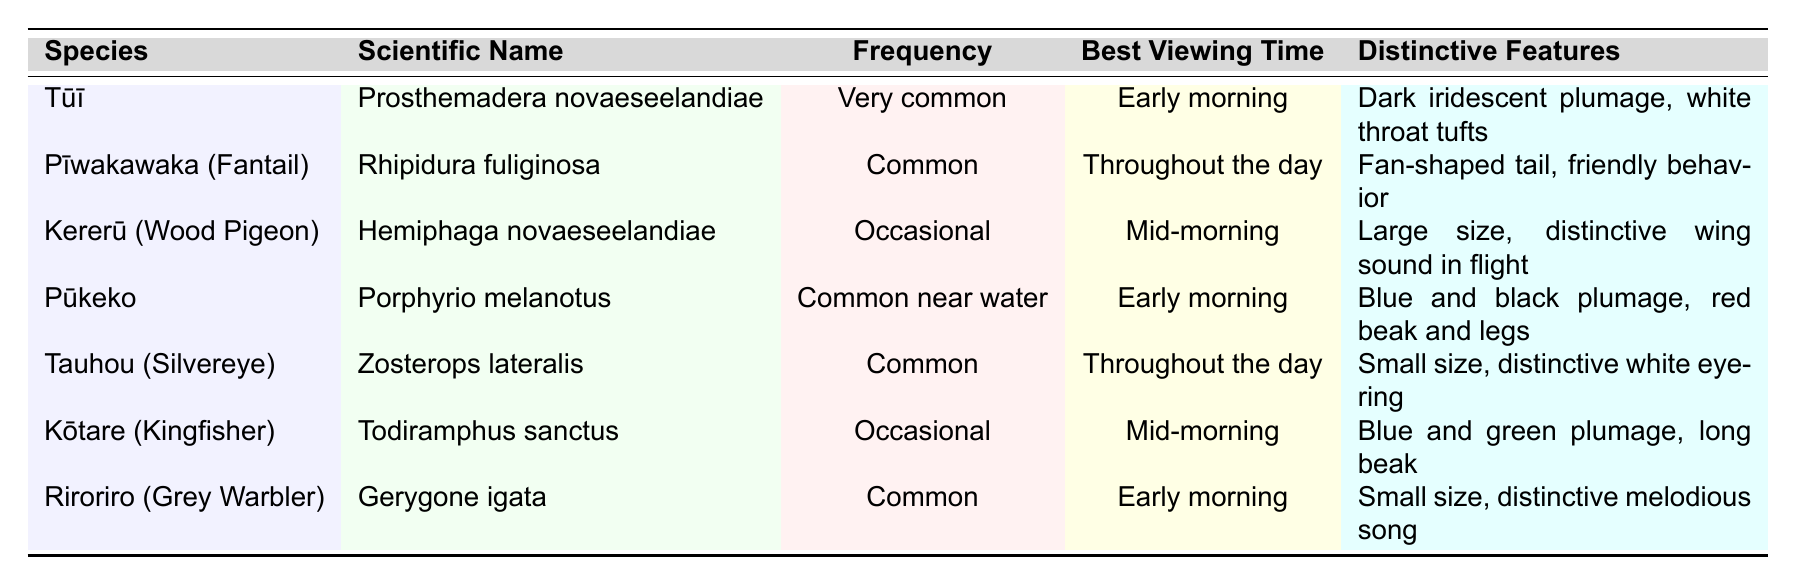What is the frequency of the Tūī? From the table, the Tūī has a frequency listed as "Very common".
Answer: Very common Which bird species have "Early morning" as the best viewing time? Referring to the table, both Tūī, Pūkeko, and Riroriro have "Early morning" listed as their best viewing time.
Answer: Tūī, Pūkeko, Riroriro How many bird species are considered "Occasional"? The table lists Kererū and Kōtare as occasional species. Thus, there are 2 species classified as occasional.
Answer: 2 Is the Pīwakawaka considered common? The table states that the Pīwakawaka is classified as "Common".
Answer: Yes Which bird has a distinctive blue and black plumage? The Pūkeko is noted in the table for having blue and black plumage.
Answer: Pūkeko Which species has the most distinctive features? The Tūī has distinctive features mentioned as "Dark iridescent plumage, white throat tufts," which stands out compared to others.
Answer: Tūī What is the difference in frequency between very common and occasional bird species? There are 4 species listed as "Common" (Pīwakawaka, Tauhou, and Riroriro), while there are 2 species listed as "Occasional" (Kererū, Kōtare). The difference is 4 - 2 = 2.
Answer: 2 What is the best viewing time for the Kererū? According to the table, the Kererū's best viewing time is "Mid-morning".
Answer: Mid-morning Name the bird species that are common near water. The table specifies that the Pūkeko is common near water.
Answer: Pūkeko Which species can be viewed throughout the day? The Pīwakawaka and Tauhou are both mentioned as species that can be viewed throughout the day.
Answer: Pīwakawaka, Tauhou How many bird species have a long beak? The Kōtare's distinctive feature is a long beak, and it is the only one noted in the table with this characteristic.
Answer: 1 